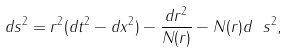Convert formula to latex. <formula><loc_0><loc_0><loc_500><loc_500>d s ^ { 2 } = r ^ { 2 } ( d t ^ { 2 } - d x ^ { 2 } ) - \frac { d r ^ { 2 } } { N ( r ) } - N ( r ) d \ s ^ { 2 } ,</formula> 